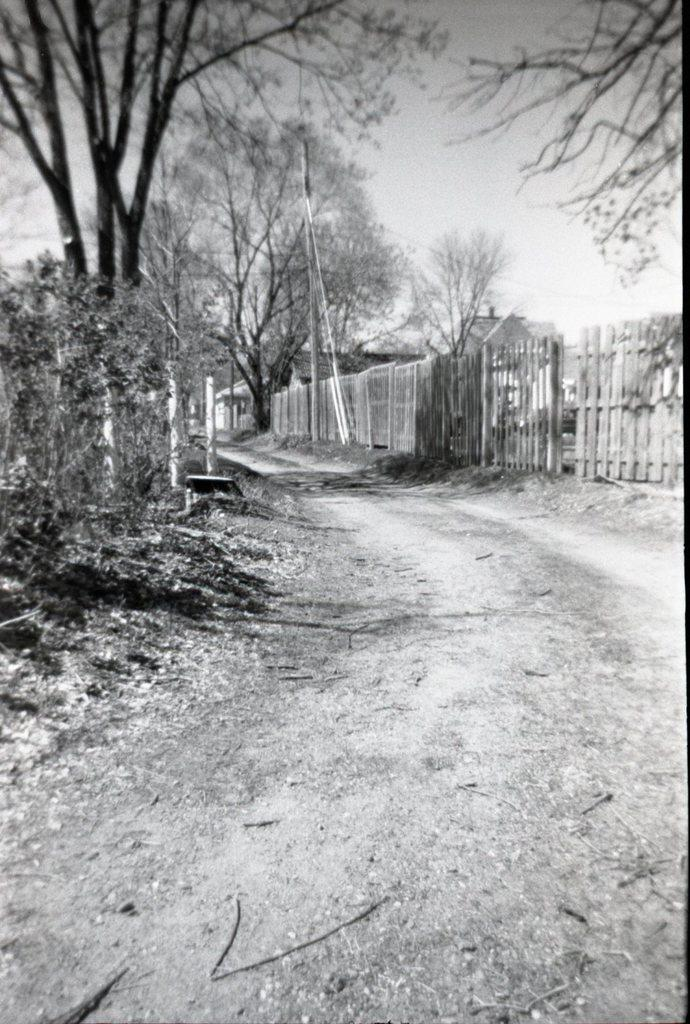What type of natural elements can be seen in the image? There are trees and plants in the image. What man-made structures are present in the image? There are small poles, a fence, a building, and a road in the image. What part of the natural environment is visible in the image? The sky is visible in the image. How many deer can be seen grazing on the plants in the image? There are no deer present in the image; it features trees, plants, small poles, a fence, a building, a road, and the sky. What type of beds are visible in the image? There are no beds present in the image. 